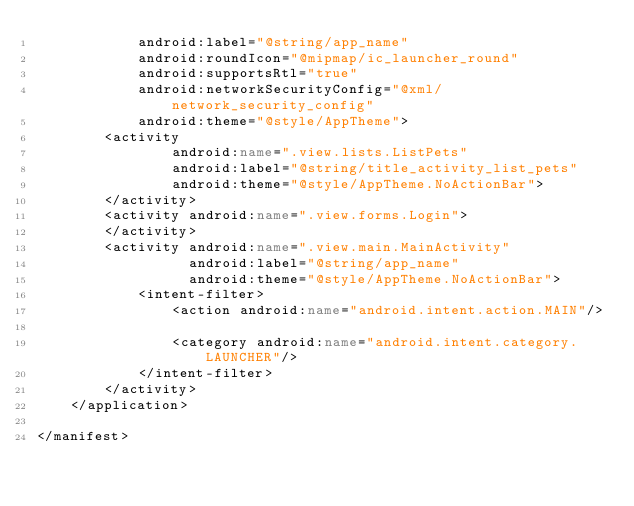<code> <loc_0><loc_0><loc_500><loc_500><_XML_>            android:label="@string/app_name"
            android:roundIcon="@mipmap/ic_launcher_round"
            android:supportsRtl="true"
            android:networkSecurityConfig="@xml/network_security_config"
            android:theme="@style/AppTheme">
        <activity
                android:name=".view.lists.ListPets"
                android:label="@string/title_activity_list_pets"
                android:theme="@style/AppTheme.NoActionBar">
        </activity>
        <activity android:name=".view.forms.Login">
        </activity>
        <activity android:name=".view.main.MainActivity"
                  android:label="@string/app_name"
                  android:theme="@style/AppTheme.NoActionBar">
            <intent-filter>
                <action android:name="android.intent.action.MAIN"/>

                <category android:name="android.intent.category.LAUNCHER"/>
            </intent-filter>
        </activity>
    </application>

</manifest></code> 